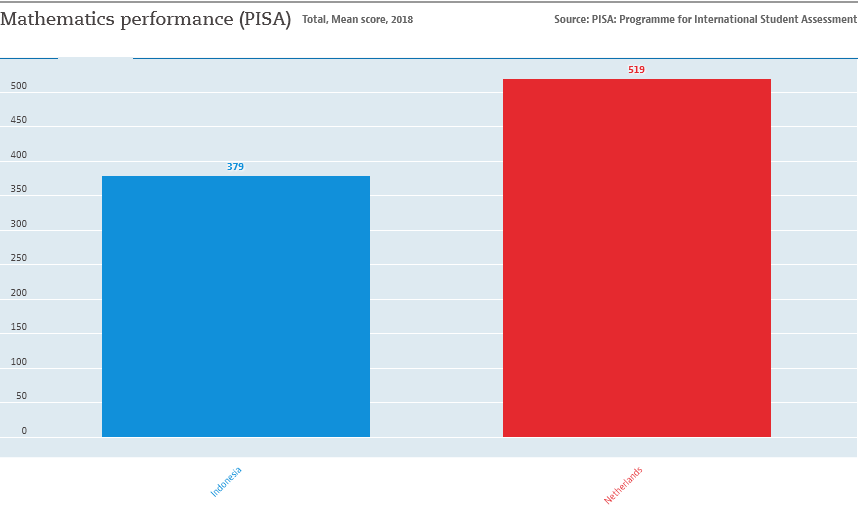Outline some significant characteristics in this image. The value of the longest bar is 519. The sum value of both bars is 898. 